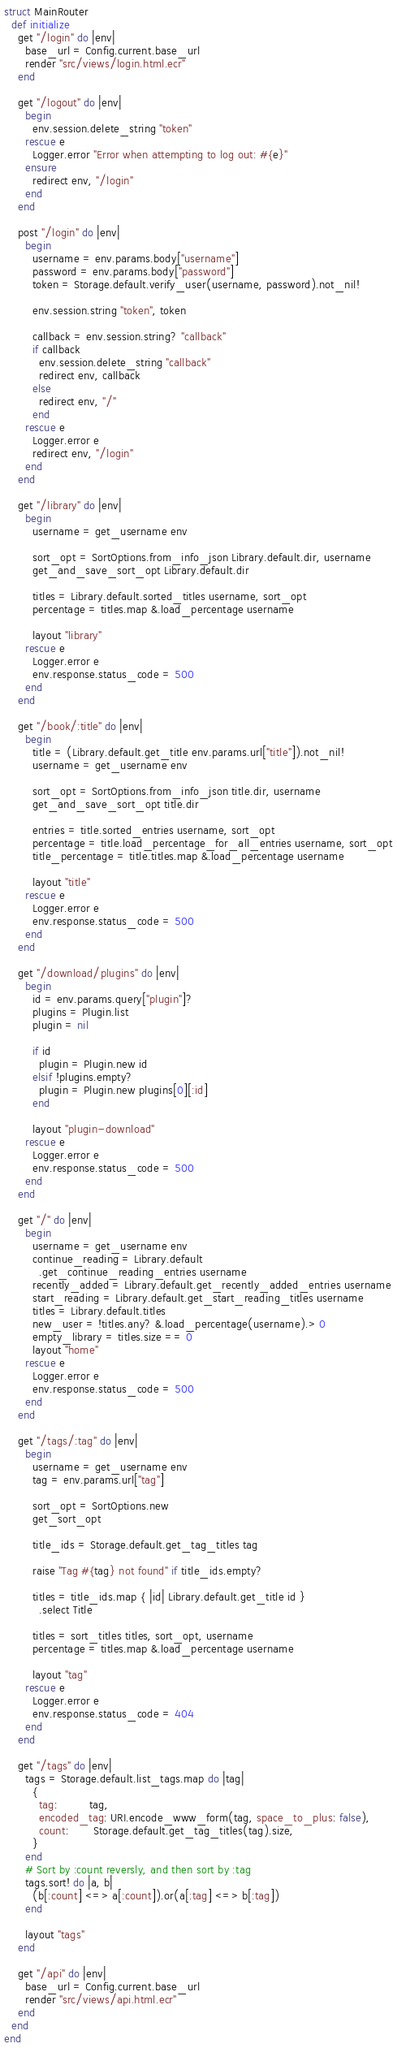<code> <loc_0><loc_0><loc_500><loc_500><_Crystal_>struct MainRouter
  def initialize
    get "/login" do |env|
      base_url = Config.current.base_url
      render "src/views/login.html.ecr"
    end

    get "/logout" do |env|
      begin
        env.session.delete_string "token"
      rescue e
        Logger.error "Error when attempting to log out: #{e}"
      ensure
        redirect env, "/login"
      end
    end

    post "/login" do |env|
      begin
        username = env.params.body["username"]
        password = env.params.body["password"]
        token = Storage.default.verify_user(username, password).not_nil!

        env.session.string "token", token

        callback = env.session.string? "callback"
        if callback
          env.session.delete_string "callback"
          redirect env, callback
        else
          redirect env, "/"
        end
      rescue e
        Logger.error e
        redirect env, "/login"
      end
    end

    get "/library" do |env|
      begin
        username = get_username env

        sort_opt = SortOptions.from_info_json Library.default.dir, username
        get_and_save_sort_opt Library.default.dir

        titles = Library.default.sorted_titles username, sort_opt
        percentage = titles.map &.load_percentage username

        layout "library"
      rescue e
        Logger.error e
        env.response.status_code = 500
      end
    end

    get "/book/:title" do |env|
      begin
        title = (Library.default.get_title env.params.url["title"]).not_nil!
        username = get_username env

        sort_opt = SortOptions.from_info_json title.dir, username
        get_and_save_sort_opt title.dir

        entries = title.sorted_entries username, sort_opt
        percentage = title.load_percentage_for_all_entries username, sort_opt
        title_percentage = title.titles.map &.load_percentage username

        layout "title"
      rescue e
        Logger.error e
        env.response.status_code = 500
      end
    end

    get "/download/plugins" do |env|
      begin
        id = env.params.query["plugin"]?
        plugins = Plugin.list
        plugin = nil

        if id
          plugin = Plugin.new id
        elsif !plugins.empty?
          plugin = Plugin.new plugins[0][:id]
        end

        layout "plugin-download"
      rescue e
        Logger.error e
        env.response.status_code = 500
      end
    end

    get "/" do |env|
      begin
        username = get_username env
        continue_reading = Library.default
          .get_continue_reading_entries username
        recently_added = Library.default.get_recently_added_entries username
        start_reading = Library.default.get_start_reading_titles username
        titles = Library.default.titles
        new_user = !titles.any? &.load_percentage(username).> 0
        empty_library = titles.size == 0
        layout "home"
      rescue e
        Logger.error e
        env.response.status_code = 500
      end
    end

    get "/tags/:tag" do |env|
      begin
        username = get_username env
        tag = env.params.url["tag"]

        sort_opt = SortOptions.new
        get_sort_opt

        title_ids = Storage.default.get_tag_titles tag

        raise "Tag #{tag} not found" if title_ids.empty?

        titles = title_ids.map { |id| Library.default.get_title id }
          .select Title

        titles = sort_titles titles, sort_opt, username
        percentage = titles.map &.load_percentage username

        layout "tag"
      rescue e
        Logger.error e
        env.response.status_code = 404
      end
    end

    get "/tags" do |env|
      tags = Storage.default.list_tags.map do |tag|
        {
          tag:         tag,
          encoded_tag: URI.encode_www_form(tag, space_to_plus: false),
          count:       Storage.default.get_tag_titles(tag).size,
        }
      end
      # Sort by :count reversly, and then sort by :tag
      tags.sort! do |a, b|
        (b[:count] <=> a[:count]).or(a[:tag] <=> b[:tag])
      end

      layout "tags"
    end

    get "/api" do |env|
      base_url = Config.current.base_url
      render "src/views/api.html.ecr"
    end
  end
end
</code> 